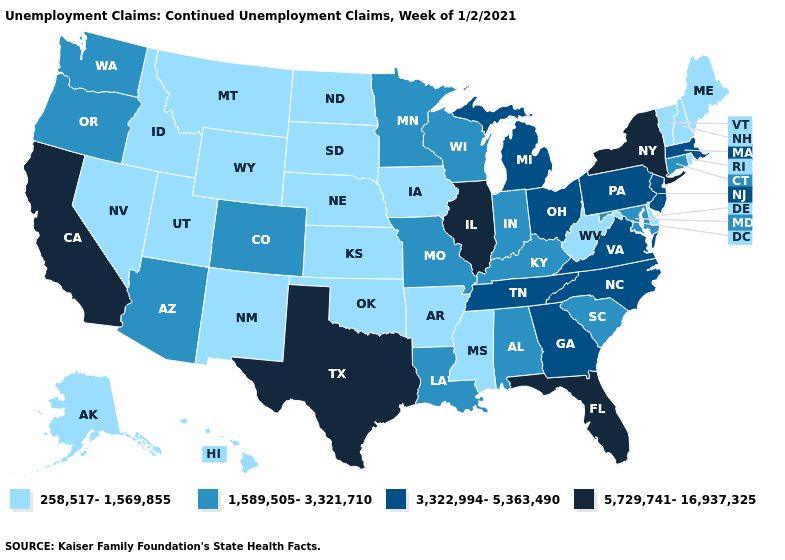Name the states that have a value in the range 1,589,505-3,321,710?
Short answer required. Alabama, Arizona, Colorado, Connecticut, Indiana, Kentucky, Louisiana, Maryland, Minnesota, Missouri, Oregon, South Carolina, Washington, Wisconsin. Does Texas have the same value as New York?
Give a very brief answer. Yes. Among the states that border Connecticut , which have the highest value?
Write a very short answer. New York. Among the states that border Connecticut , does New York have the highest value?
Answer briefly. Yes. What is the value of Georgia?
Short answer required. 3,322,994-5,363,490. How many symbols are there in the legend?
Be succinct. 4. Does the first symbol in the legend represent the smallest category?
Short answer required. Yes. Among the states that border Montana , which have the highest value?
Short answer required. Idaho, North Dakota, South Dakota, Wyoming. Does California have the highest value in the West?
Keep it brief. Yes. What is the value of Nebraska?
Give a very brief answer. 258,517-1,569,855. Does Oregon have a higher value than Maine?
Write a very short answer. Yes. Name the states that have a value in the range 258,517-1,569,855?
Write a very short answer. Alaska, Arkansas, Delaware, Hawaii, Idaho, Iowa, Kansas, Maine, Mississippi, Montana, Nebraska, Nevada, New Hampshire, New Mexico, North Dakota, Oklahoma, Rhode Island, South Dakota, Utah, Vermont, West Virginia, Wyoming. Is the legend a continuous bar?
Short answer required. No. Which states hav the highest value in the Northeast?
Short answer required. New York. 